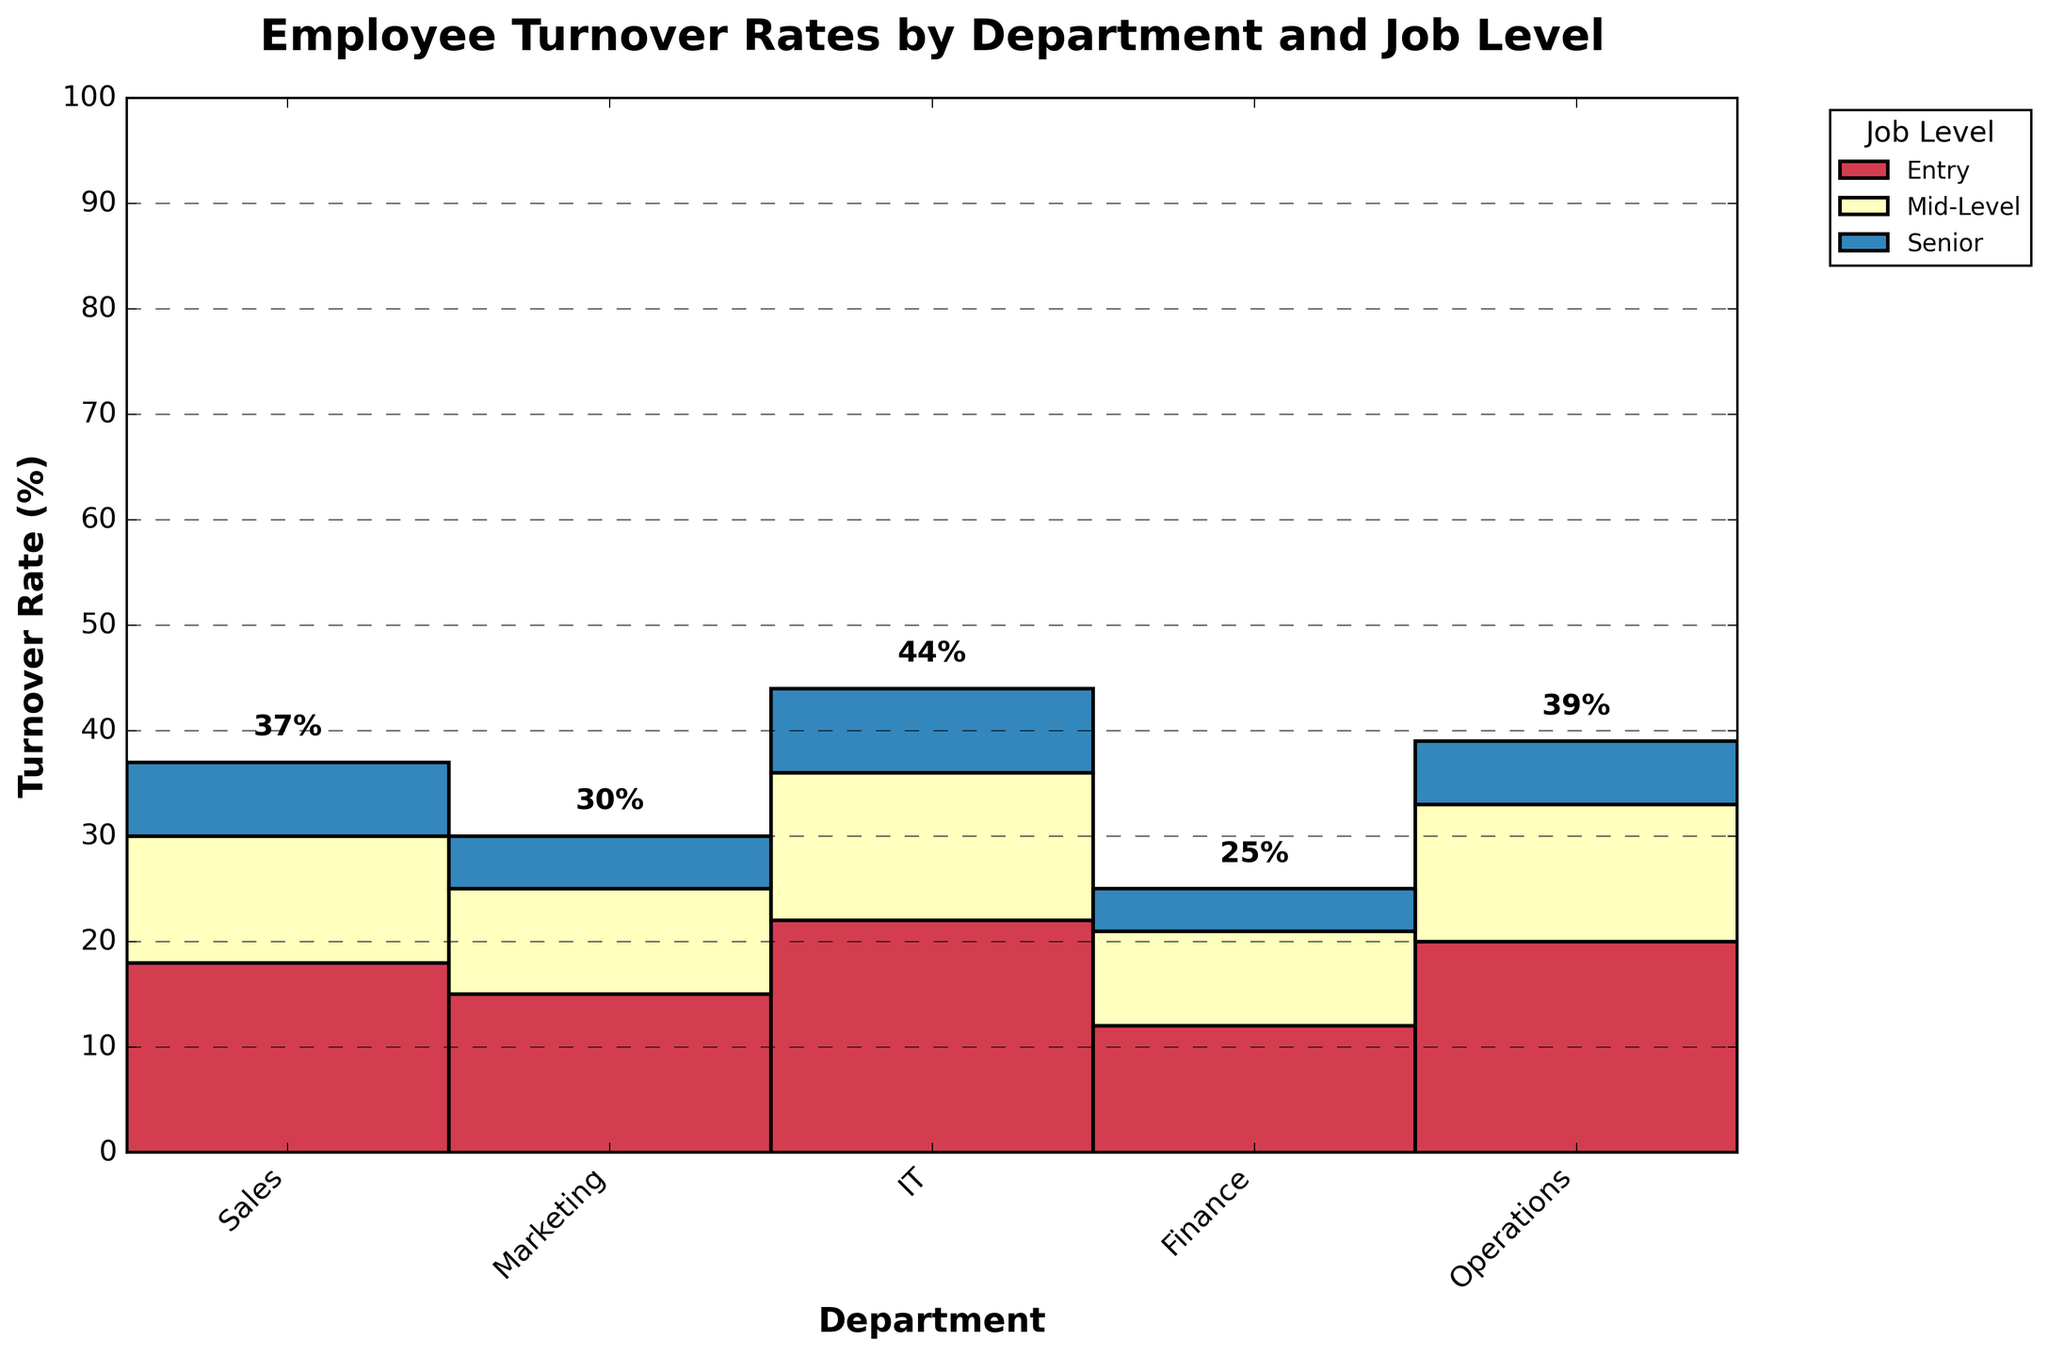Which department has the lowest turnover rate for senior job levels? To find the department with the lowest turnover rate for senior job levels, refer to the bottom segments of each bar representing each department. The bar segment with the shortest height represents the lowest turnover rate.
Answer: Finance What is the total turnover rate in the IT department? Sum the turnover rates for entry, mid-level, and senior job levels in the IT department: 22% (Entry) + 14% (Mid-Level) + 8% (Senior).
Answer: 44% Which job level generally has the highest turnover rates across all departments? Look at the colors corresponding to each job level across all department bars. The job level color that consistently appears as the tallest segment is the one with the highest turnover rate.
Answer: Entry What is the difference in turnover rate between entry and senior job levels in the Sales department? Identify the turnover rates for entry (18%) and senior (7%) job levels in the Sales department. Calculate the difference: 18% - 7%.
Answer: 11% Which department shows a higher turnover rate at the Mid-Level, Marketing or Operations? Compare the height of the mid-level segments in the Marketing and Operations department bars.
Answer: Operations Which departments have a turnover rate of more than 10% at the Senior job level? Look at the senior job level segments in all department bars. Identify segments taller than the 10% mark on the y-axis.
Answer: None What is the highest turnover rate observed in the figure, and in which department and job level does it occur? Scan the figure for the highest bar segment and note the corresponding department and job level.
Answer: IT, Entry How much higher is the overall turnover rate in the Operations department compared to the Finance department? Calculate the total turnover for Operations: 20% (Entry) + 13% (Mid-Level) + 6% (Senior) and Finance: 12% (Entry) + 9% (Mid-Level) + 4% (Senior). Find the difference between the two totals.
Answer: 14% Which department has the most balanced turnover rates across all job levels? Observe the bars and find the department where the height difference between different job levels is the smallest.
Answer: Finance What is the cumulative turnover rate for senior positions across all departments? Sum the turnover rates for senior job levels of all departments: 7% (Sales) + 5% (Marketing) + 8% (IT) + 4% (Finance) + 6% (Operations).
Answer: 30% 